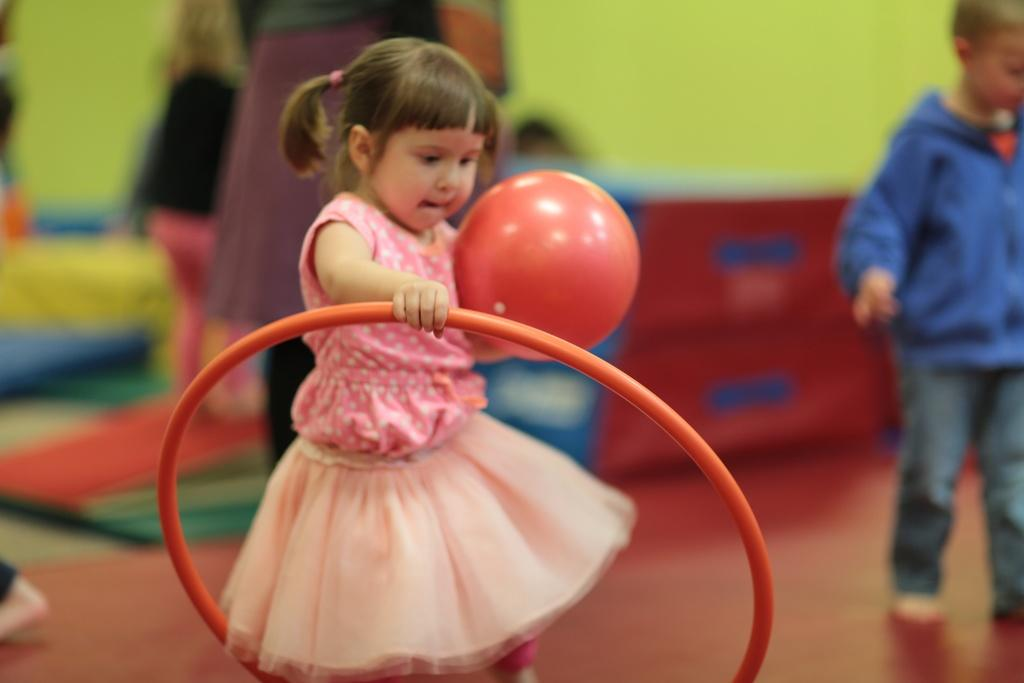What is the main subject of the image? The main subject of the image is a kid standing in the center. What is the kid holding in the image? The kid is holding a balloon and an unspecified object. What can be seen in the background of the image? There is a wall, a play area, and people standing in the background. What type of reaction does the potato have when it sees the mailbox in the image? There is no potato or mailbox present in the image, so it is not possible to determine any reaction. 